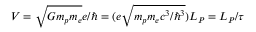<formula> <loc_0><loc_0><loc_500><loc_500>V = \sqrt { G m _ { p } m _ { e } } e / \hbar { = } ( e \sqrt { m _ { p } m _ { e } c ^ { 3 } / \hbar { ^ } { 3 } } ) L _ { P } = L _ { P } / \tau</formula> 